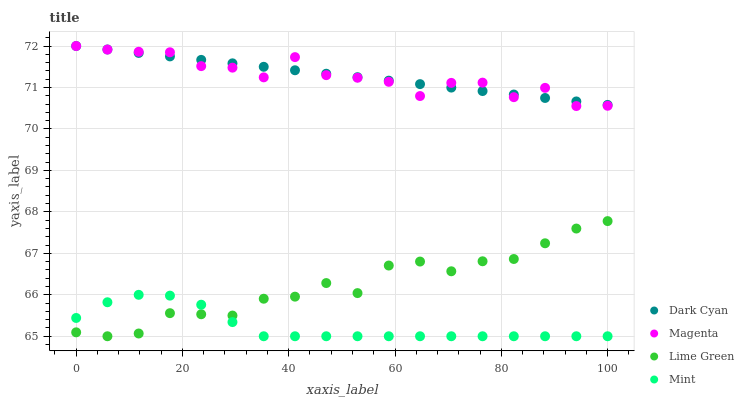Does Mint have the minimum area under the curve?
Answer yes or no. Yes. Does Dark Cyan have the maximum area under the curve?
Answer yes or no. Yes. Does Magenta have the minimum area under the curve?
Answer yes or no. No. Does Magenta have the maximum area under the curve?
Answer yes or no. No. Is Dark Cyan the smoothest?
Answer yes or no. Yes. Is Magenta the roughest?
Answer yes or no. Yes. Is Mint the smoothest?
Answer yes or no. No. Is Mint the roughest?
Answer yes or no. No. Does Mint have the lowest value?
Answer yes or no. Yes. Does Magenta have the lowest value?
Answer yes or no. No. Does Magenta have the highest value?
Answer yes or no. Yes. Does Mint have the highest value?
Answer yes or no. No. Is Lime Green less than Dark Cyan?
Answer yes or no. Yes. Is Dark Cyan greater than Lime Green?
Answer yes or no. Yes. Does Magenta intersect Dark Cyan?
Answer yes or no. Yes. Is Magenta less than Dark Cyan?
Answer yes or no. No. Is Magenta greater than Dark Cyan?
Answer yes or no. No. Does Lime Green intersect Dark Cyan?
Answer yes or no. No. 